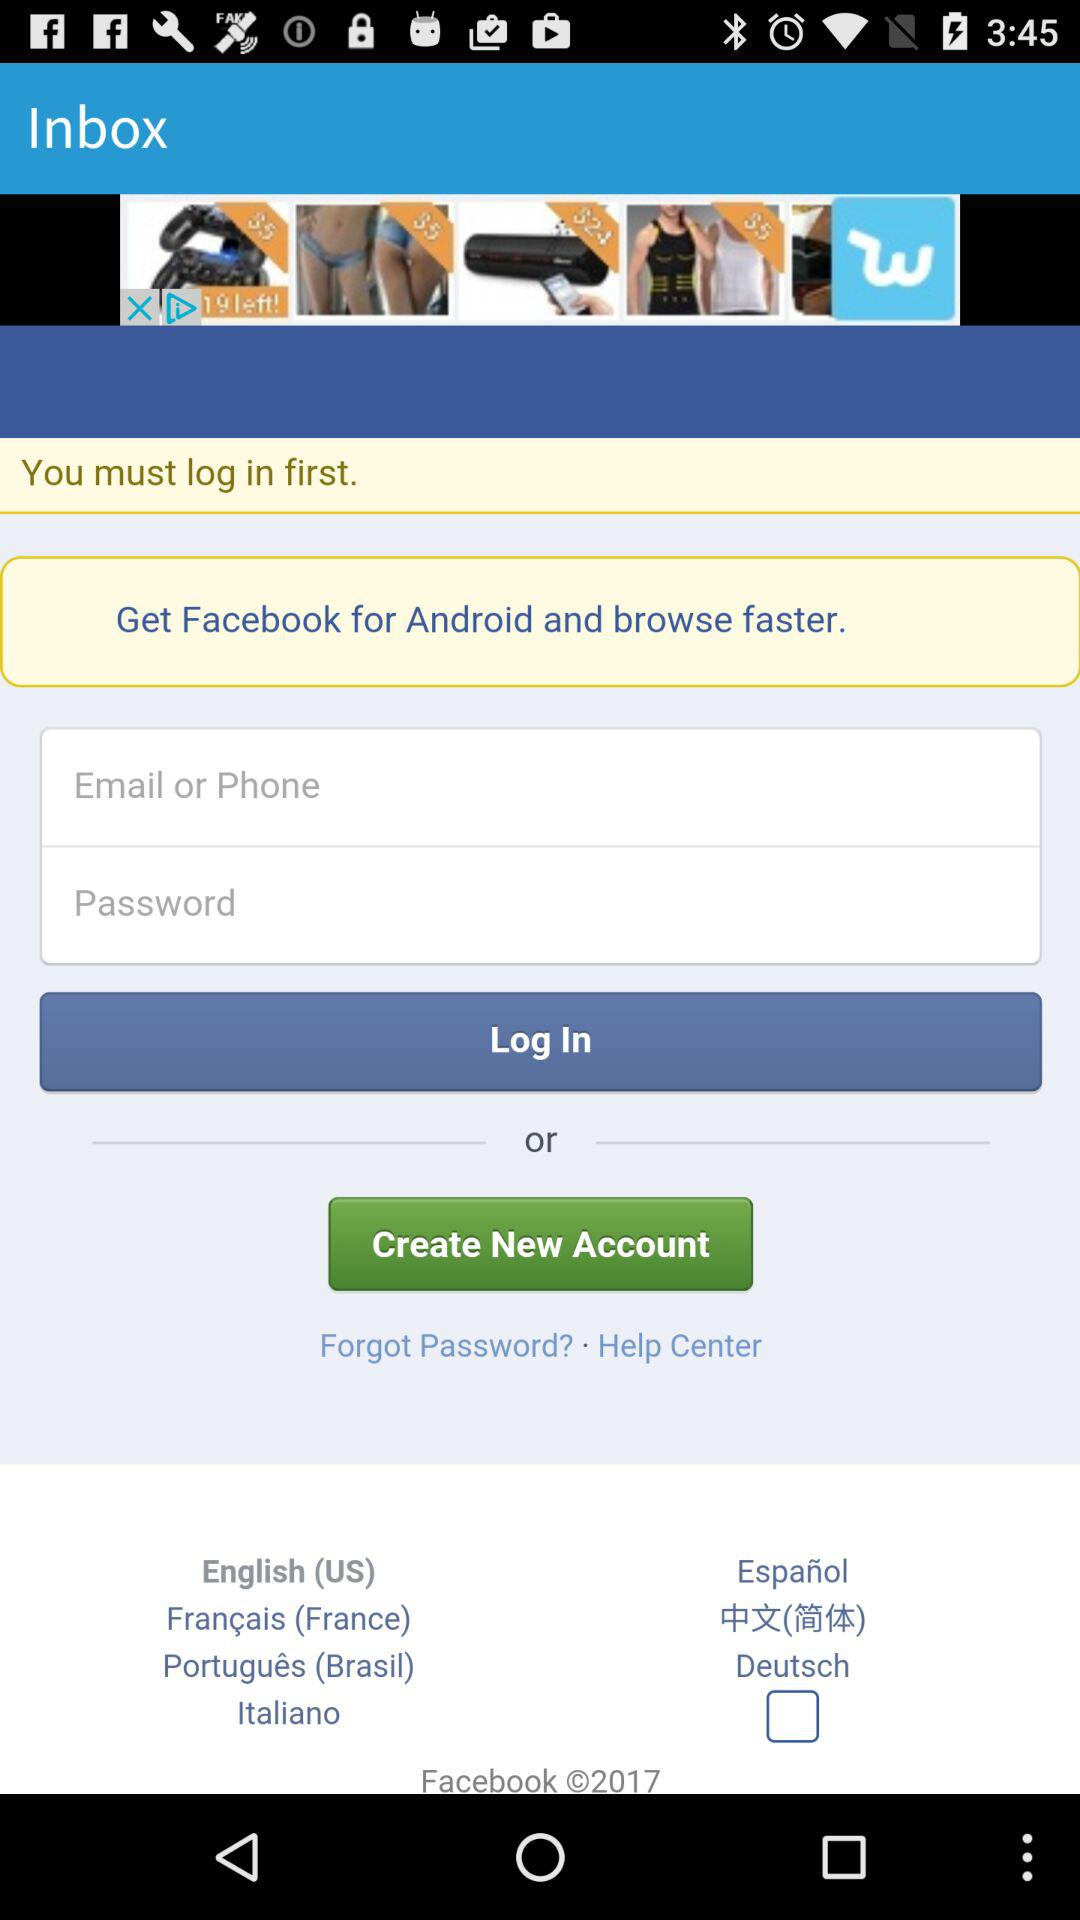How many languages are available for the user to choose from?
Answer the question using a single word or phrase. 7 